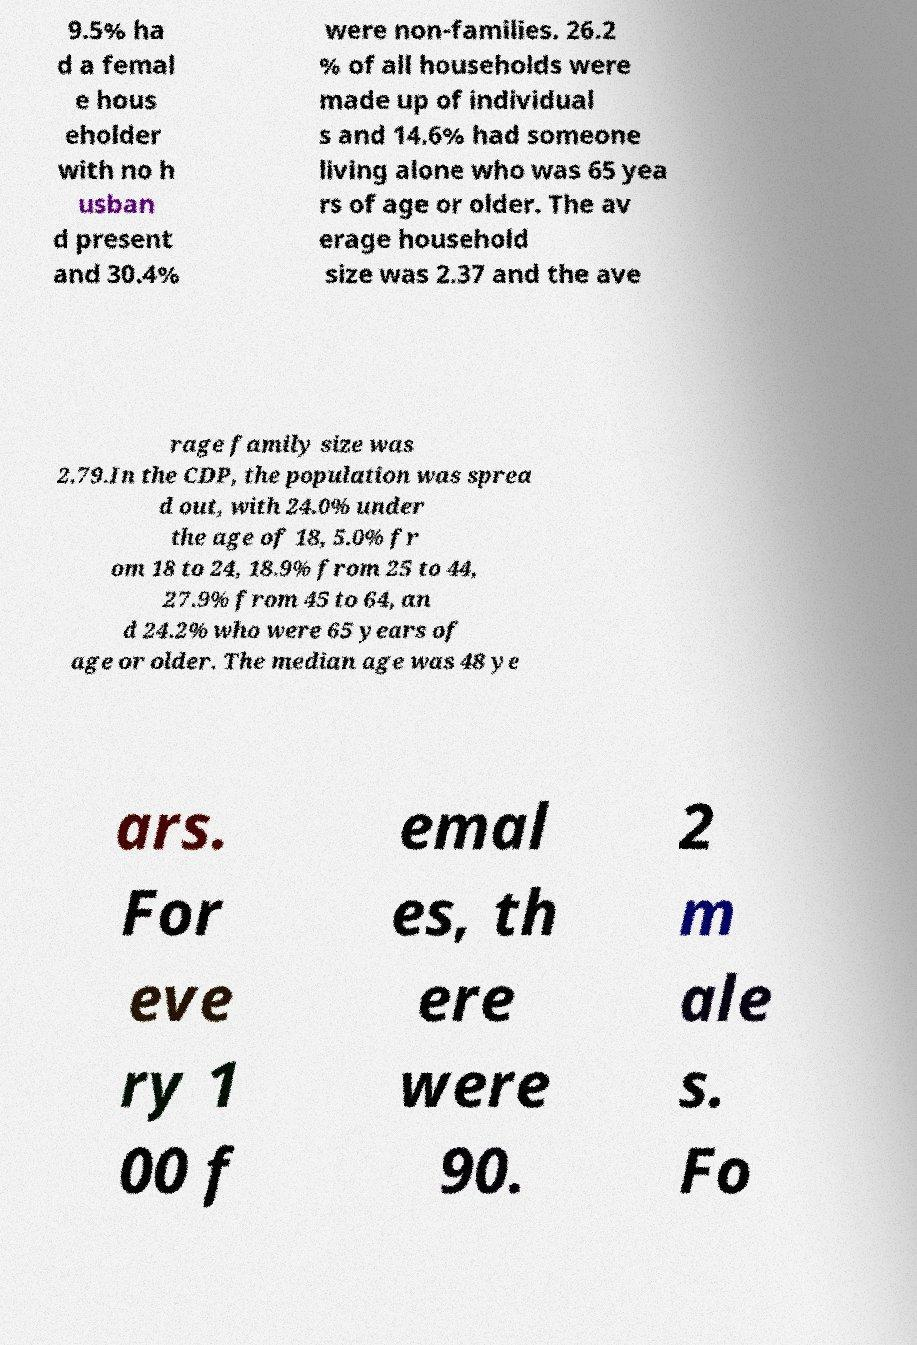Please identify and transcribe the text found in this image. 9.5% ha d a femal e hous eholder with no h usban d present and 30.4% were non-families. 26.2 % of all households were made up of individual s and 14.6% had someone living alone who was 65 yea rs of age or older. The av erage household size was 2.37 and the ave rage family size was 2.79.In the CDP, the population was sprea d out, with 24.0% under the age of 18, 5.0% fr om 18 to 24, 18.9% from 25 to 44, 27.9% from 45 to 64, an d 24.2% who were 65 years of age or older. The median age was 48 ye ars. For eve ry 1 00 f emal es, th ere were 90. 2 m ale s. Fo 